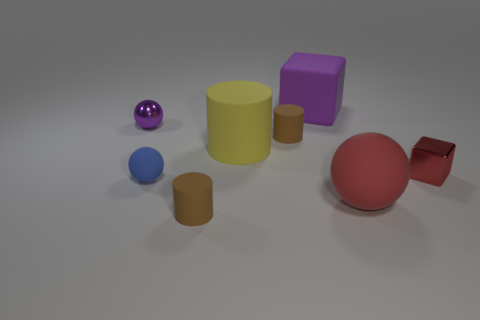How many tiny purple objects are the same shape as the blue rubber object?
Provide a succinct answer. 1. What size is the cube that is the same material as the yellow cylinder?
Offer a very short reply. Large. Is the size of the rubber block the same as the yellow cylinder?
Your answer should be very brief. Yes. Is there a tiny cylinder?
Offer a terse response. Yes. The block that is the same color as the tiny metal sphere is what size?
Offer a very short reply. Large. What size is the brown object that is behind the tiny sphere in front of the metallic thing that is left of the large purple rubber thing?
Provide a succinct answer. Small. How many brown objects are made of the same material as the tiny red thing?
Your answer should be compact. 0. What number of cylinders have the same size as the red metallic block?
Keep it short and to the point. 2. What material is the purple thing left of the cube that is to the left of the tiny metallic thing that is right of the yellow matte cylinder made of?
Provide a short and direct response. Metal. How many objects are either large purple objects or large red balls?
Give a very brief answer. 2. 